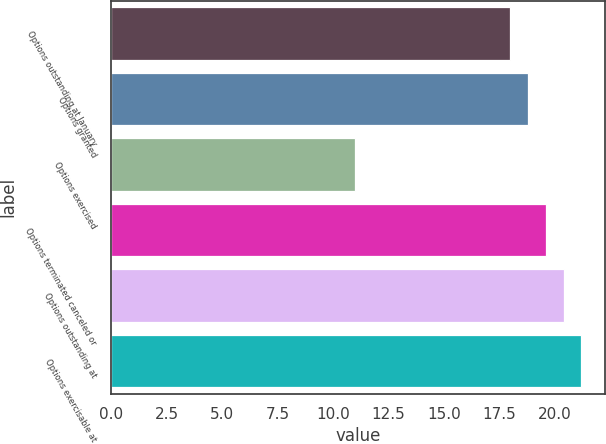Convert chart to OTSL. <chart><loc_0><loc_0><loc_500><loc_500><bar_chart><fcel>Options outstanding at January<fcel>Options granted<fcel>Options exercised<fcel>Options terminated canceled or<fcel>Options outstanding at<fcel>Options exercisable at<nl><fcel>18<fcel>18.8<fcel>11<fcel>19.6<fcel>20.4<fcel>21.2<nl></chart> 